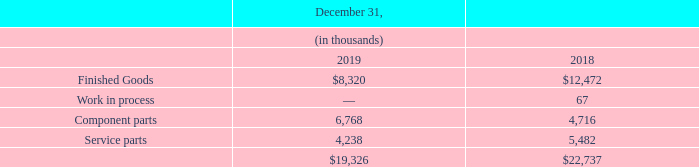Note 7 — Inventories, net
Inventories are used in the manufacture and service of Restaurant/Retail products. The components of inventory, net consist of the following:
At December 31, 2019 and 2018, the Company had recorded inventory write-downs of $9.6 million and $9.8 million , respectively, against Restaurant/Retail inventories, which relate primarily to service parts.
Where are Inventories used? In the manufacture and service of restaurant/retail products. How much was the inventory write-downs at December 31, 2019 and 2018 respectively? $9.6 million, $9.8 million. What is the value of Finished Goods in 2019 and 2018 respectively?
Answer scale should be: thousand. $8,320, $12,472. What is the change in Finished Goods between December 31, 2018 and 2019?
Answer scale should be: thousand. 8,320-12,472
Answer: -4152. What is the change in Component parts between December 31, 2018 and 2019?
Answer scale should be: thousand. 6,768-4,716
Answer: 2052. What is the average Finished Goods for December 31, 2018 and 2019?
Answer scale should be: thousand. (8,320+12,472) / 2
Answer: 10396. 